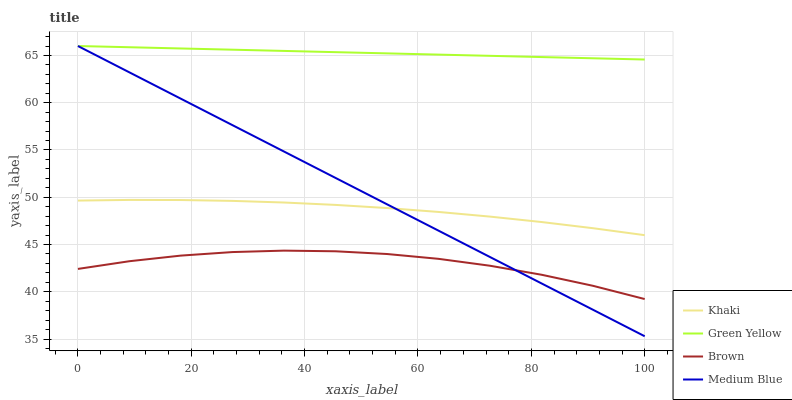Does Brown have the minimum area under the curve?
Answer yes or no. Yes. Does Green Yellow have the maximum area under the curve?
Answer yes or no. Yes. Does Khaki have the minimum area under the curve?
Answer yes or no. No. Does Khaki have the maximum area under the curve?
Answer yes or no. No. Is Green Yellow the smoothest?
Answer yes or no. Yes. Is Brown the roughest?
Answer yes or no. Yes. Is Khaki the smoothest?
Answer yes or no. No. Is Khaki the roughest?
Answer yes or no. No. Does Medium Blue have the lowest value?
Answer yes or no. Yes. Does Khaki have the lowest value?
Answer yes or no. No. Does Medium Blue have the highest value?
Answer yes or no. Yes. Does Khaki have the highest value?
Answer yes or no. No. Is Khaki less than Green Yellow?
Answer yes or no. Yes. Is Green Yellow greater than Khaki?
Answer yes or no. Yes. Does Medium Blue intersect Khaki?
Answer yes or no. Yes. Is Medium Blue less than Khaki?
Answer yes or no. No. Is Medium Blue greater than Khaki?
Answer yes or no. No. Does Khaki intersect Green Yellow?
Answer yes or no. No. 